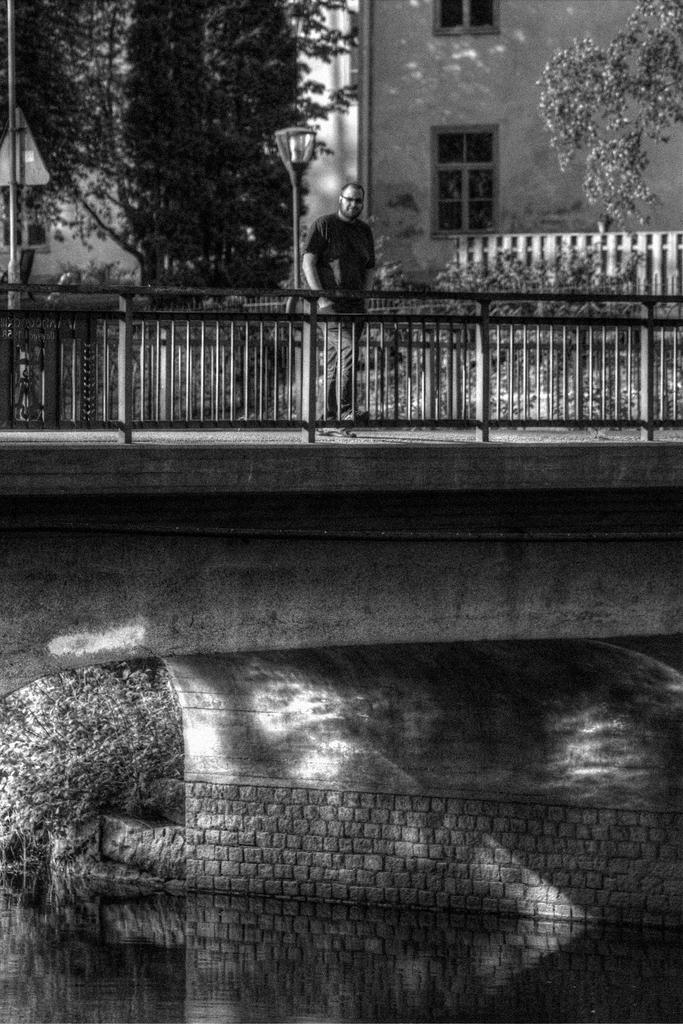What is the color scheme of the image? The image is black and white. What is the main structure featured in the image? There is a bridge in the image. Can you describe the man's position in the image? A man is standing near a railing on the bridge. What can be seen in the background of the image? There are trees and a building in the background of the image. What type of apparatus is the man using to care for his grandfather in the image? There is no apparatus or grandfather present in the image. What type of care is the man providing to his grandfather in the image? There is no grandfather or caregiving activity depicted in the image. 